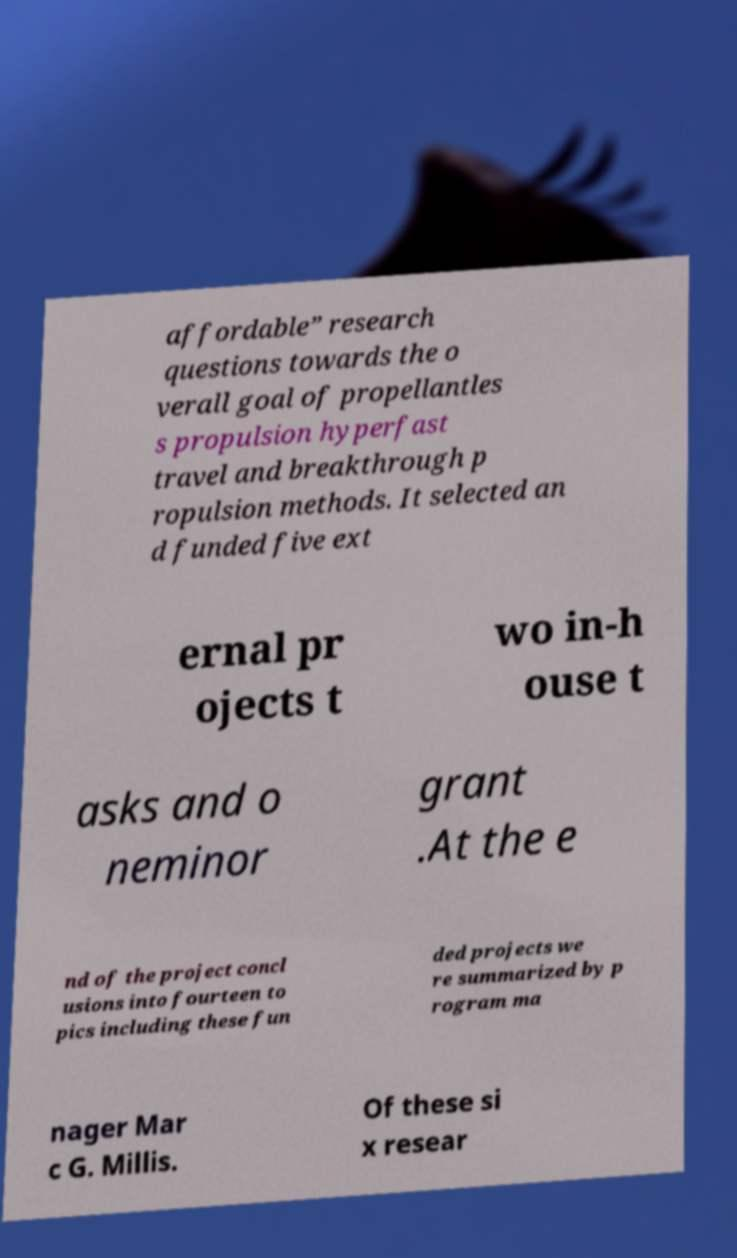I need the written content from this picture converted into text. Can you do that? affordable” research questions towards the o verall goal of propellantles s propulsion hyperfast travel and breakthrough p ropulsion methods. It selected an d funded five ext ernal pr ojects t wo in-h ouse t asks and o neminor grant .At the e nd of the project concl usions into fourteen to pics including these fun ded projects we re summarized by p rogram ma nager Mar c G. Millis. Of these si x resear 